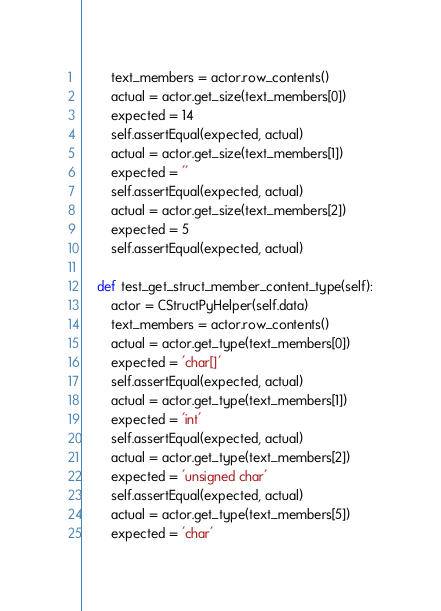Convert code to text. <code><loc_0><loc_0><loc_500><loc_500><_Python_>        text_members = actor.row_contents()
        actual = actor.get_size(text_members[0])
        expected = 14
        self.assertEqual(expected, actual)
        actual = actor.get_size(text_members[1])
        expected = ''
        self.assertEqual(expected, actual)
        actual = actor.get_size(text_members[2])
        expected = 5
        self.assertEqual(expected, actual)

    def test_get_struct_member_content_type(self):
        actor = CStructPyHelper(self.data)
        text_members = actor.row_contents()
        actual = actor.get_type(text_members[0])
        expected = 'char[]'
        self.assertEqual(expected, actual)
        actual = actor.get_type(text_members[1])
        expected = 'int'
        self.assertEqual(expected, actual)
        actual = actor.get_type(text_members[2])
        expected = 'unsigned char'
        self.assertEqual(expected, actual)
        actual = actor.get_type(text_members[5])
        expected = 'char'</code> 